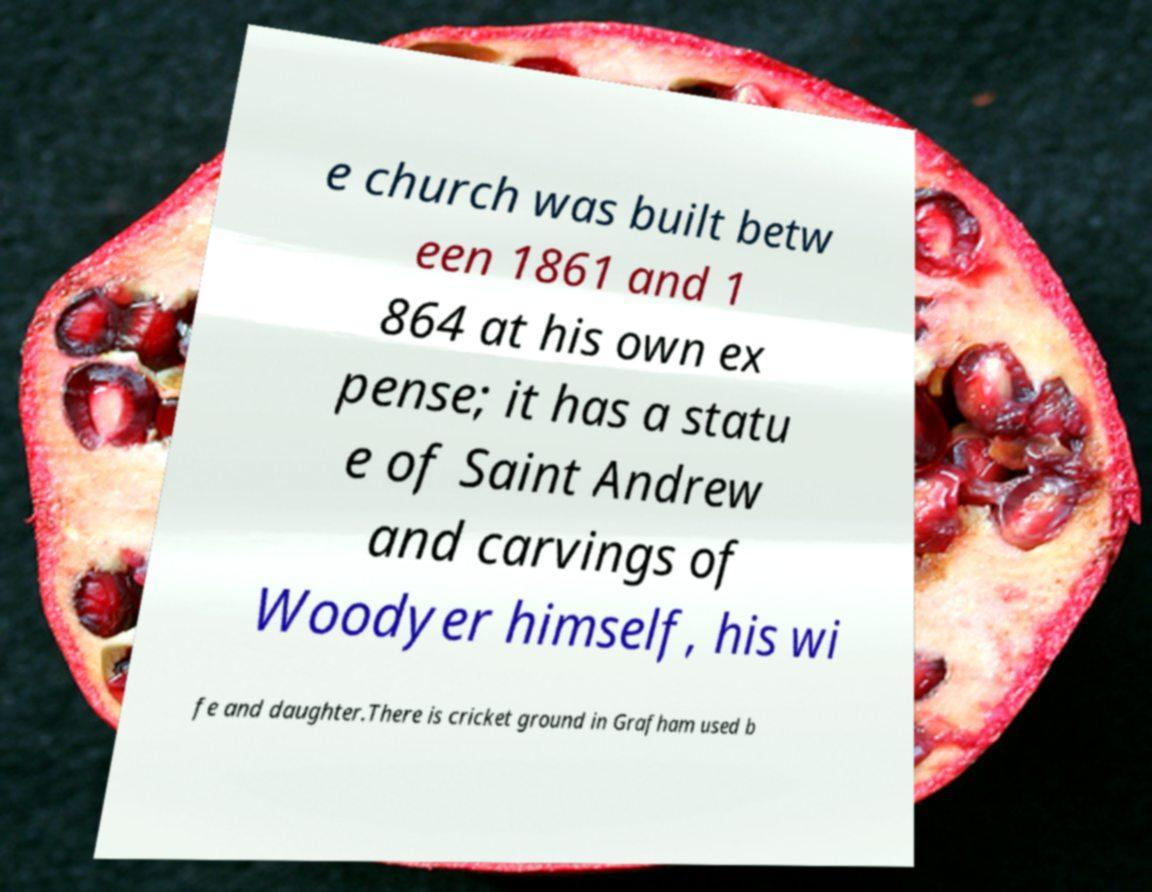Please read and relay the text visible in this image. What does it say? e church was built betw een 1861 and 1 864 at his own ex pense; it has a statu e of Saint Andrew and carvings of Woodyer himself, his wi fe and daughter.There is cricket ground in Grafham used b 